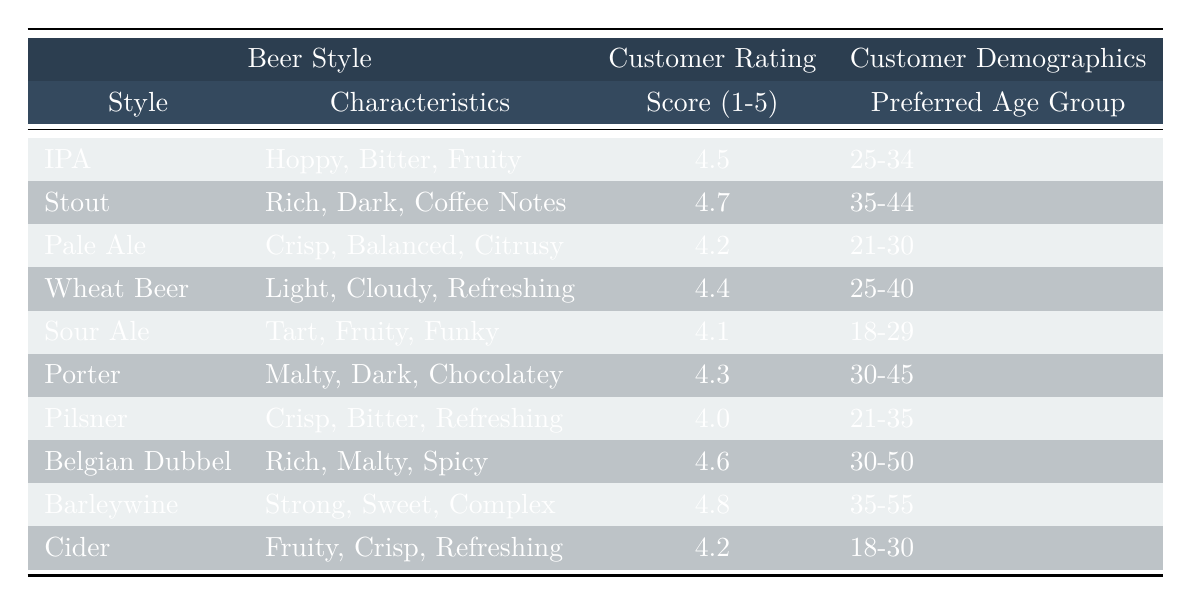What is the highest-rated beer style? Reviewing the table, the beer style with the highest score is "Barleywine," which has a score of 4.8.
Answer: Barleywine Which age group prefers Wheat Beer? The table indicates that the preferred age group for Wheat Beer is 25-40.
Answer: 25-40 What is the average score for beer styles rated between 4.0 and 4.4? The beer styles rated between 4.0 and 4.4 are Pilsner (4.0), Pale Ale (4.2), and Wheat Beer (4.4). The sum of these scores is 4.0 + 4.2 + 4.4 = 12.6. There are 3 styles, so the average score is 12.6 / 3 = 4.2.
Answer: 4.2 Is there a beer style preferred by the age group 21-30? Yes, the table shows that both Pale Ale and Cider are preferred by the age group 21-30.
Answer: Yes What are the characteristics of the beer style with the lowest rating? The beer style with the lowest rating is Pilsner, which has characteristics described as "Crisp, Bitter, Refreshing."
Answer: Crisp, Bitter, Refreshing How many beer styles have a rating above 4.5? The beer styles with ratings above 4.5 are Stout (4.7), Belgian Dubbel (4.6), and Barleywine (4.8), totaling 3 styles.
Answer: 3 Is Sour Ale more preferred by the younger demographic compared to Porter? Comparing the age demographics, Sour Ale has a preferred age group of 18-29, while Porter is preferred by the age group 30-45. Younger customers prefer Sour Ale.
Answer: Yes What is the score difference between the highest and the lowest-rated beer styles? The highest-rated style is Barleywine with a score of 4.8, and the lowest is Pilsner with a score of 4.0. The difference is 4.8 - 4.0 = 0.8.
Answer: 0.8 Which beer style has the characteristics "Rich, Dark, Coffee Notes"? The style with these characteristics is Stout, as noted in the table.
Answer: Stout What is the preferred age group for the beer style with the highest score? The beer style with the highest score, Barleywine, is preferred by the age group 35-55.
Answer: 35-55 